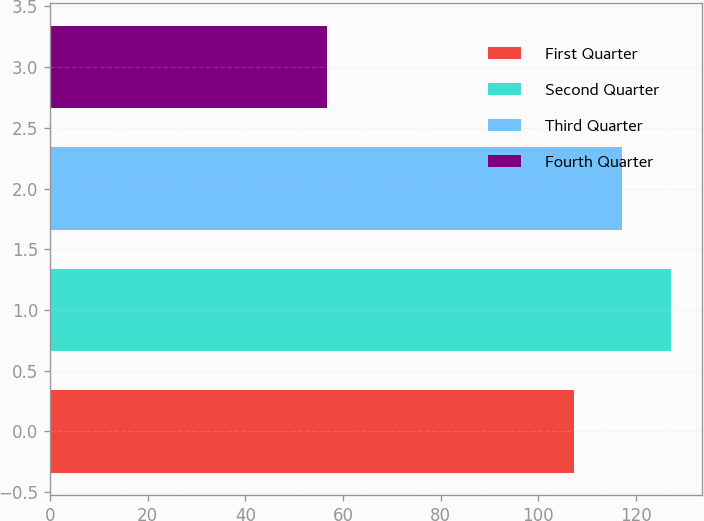<chart> <loc_0><loc_0><loc_500><loc_500><bar_chart><fcel>First Quarter<fcel>Second Quarter<fcel>Third Quarter<fcel>Fourth Quarter<nl><fcel>107.37<fcel>127.24<fcel>117.11<fcel>56.75<nl></chart> 